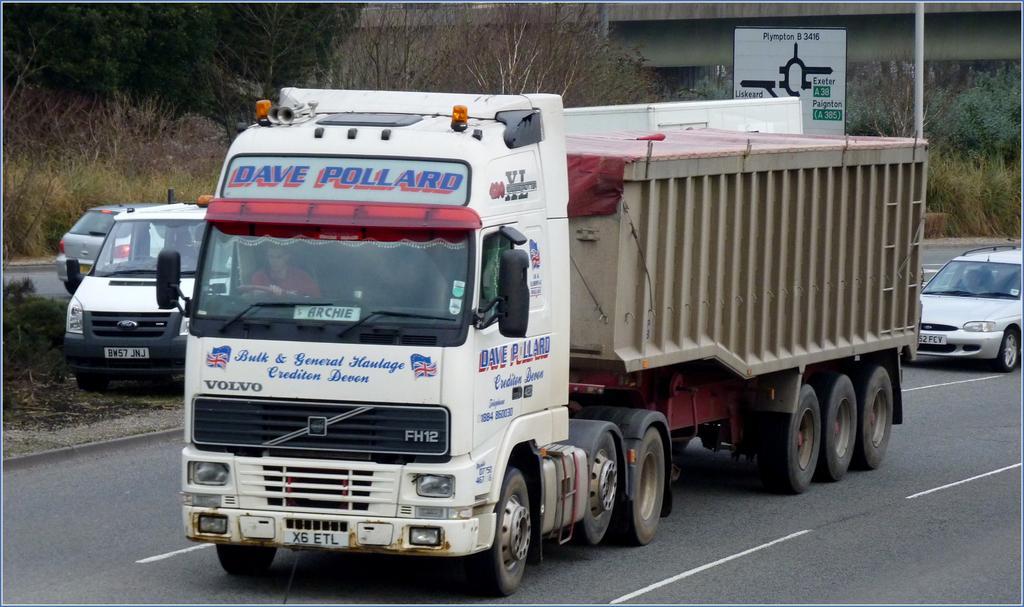Please provide a concise description of this image. As we can see in the image there is a truck, cars, banner and trees. In the background there is a bridge. 